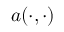Convert formula to latex. <formula><loc_0><loc_0><loc_500><loc_500>a ( \cdot , \cdot )</formula> 